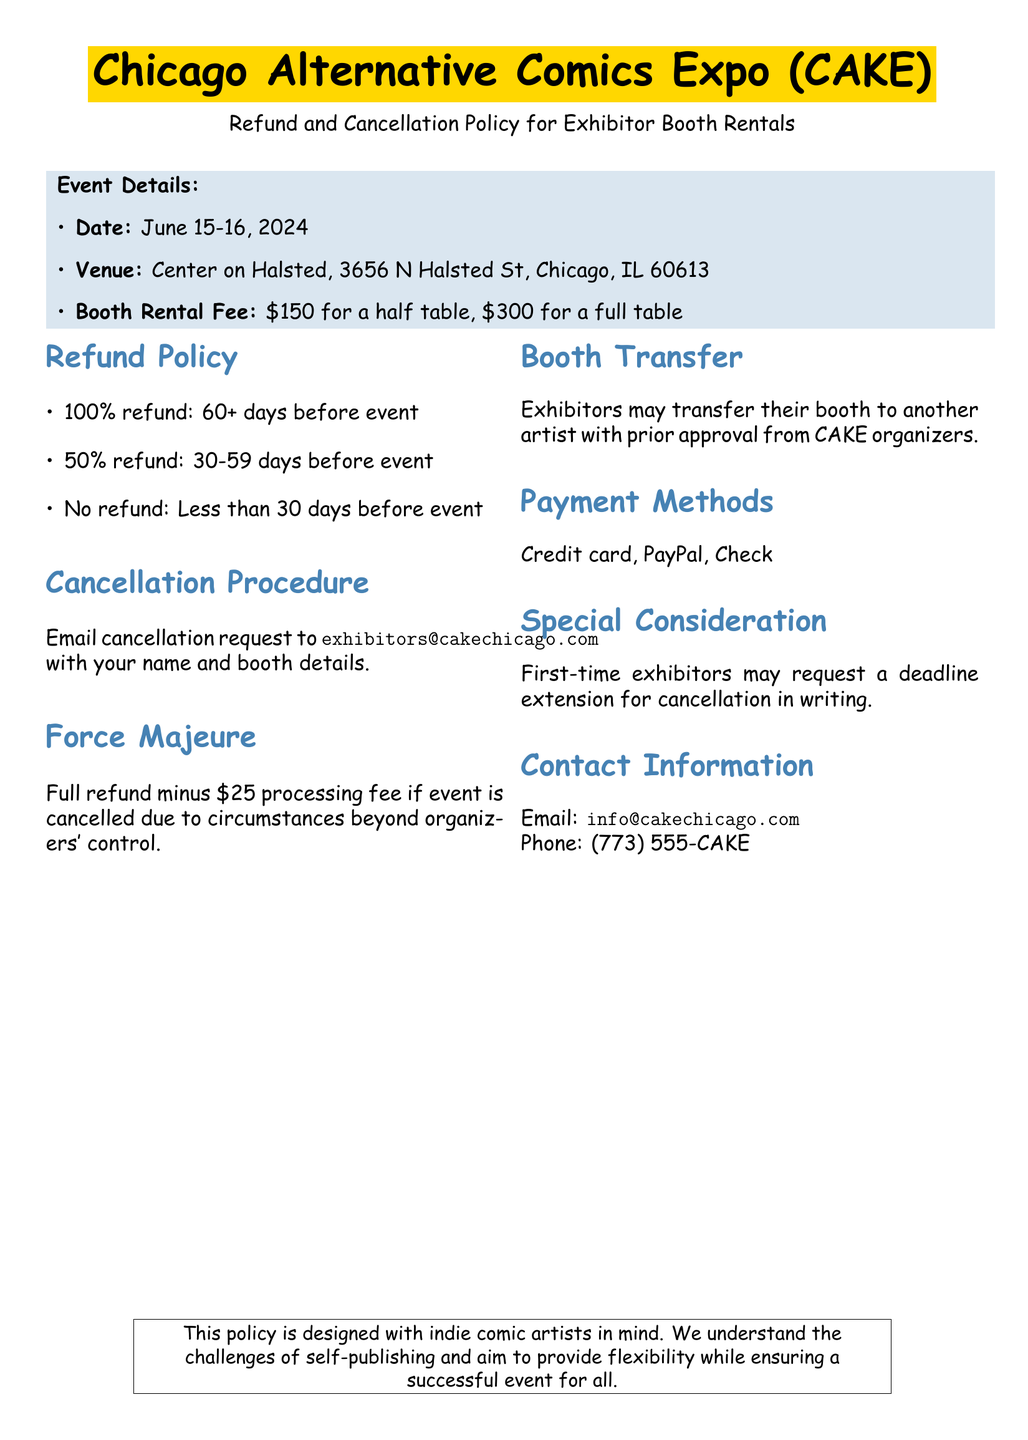What is the date of the event? The event date is clearly stated in the document.
Answer: June 15-16, 2024 What is the venue for the expo? The venue information is listed under Event Details.
Answer: Center on Halsted What is the fee for a full table? The booth rental fee information includes specific amounts for different table sizes.
Answer: $300 What is the refund percentage if I cancel 45 days before the event? The refund policy specifies percentages based on the timing of the cancellation.
Answer: 50% refund What is the email address for cancellation requests? The document provides specific contact information for cancellation procedures.
Answer: exhibitors@cakechicago.com What should first-time exhibitors do if they need a deadline extension? The document mentions a special consideration for first-time exhibitors.
Answer: Request in writing What is the processing fee for cancellations due to force majeure? The force majeure section indicates a specific processing fee.
Answer: $25 How can exhibitors pay for their booth rental? The payment methods are clearly listed in the document.
Answer: Credit card, PayPal, Check Can I transfer my booth to another artist? The booth transfer information indicates the possibility of transferring with approval.
Answer: Yes, with approval 